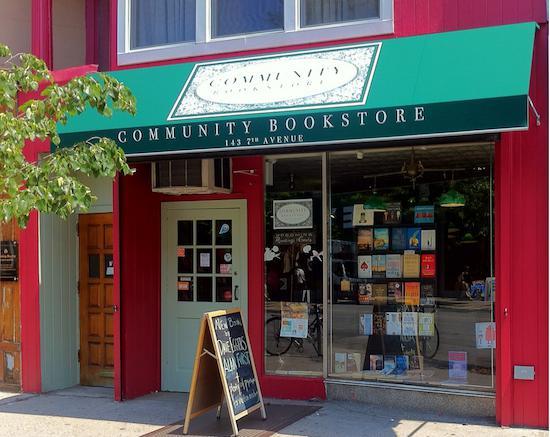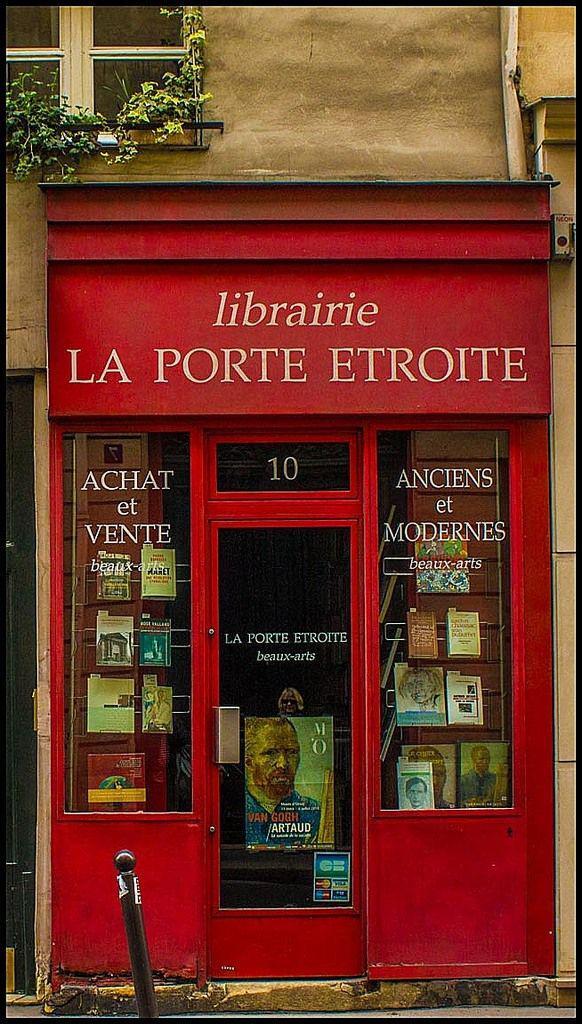The first image is the image on the left, the second image is the image on the right. Analyze the images presented: Is the assertion "The left image depicts a painted red bookshop exterior with some type of awning over its front door and display window." valid? Answer yes or no. Yes. The first image is the image on the left, the second image is the image on the right. For the images displayed, is the sentence "there is a bookstore in a brick building with green painted trim on the door and window" factually correct? Answer yes or no. No. 